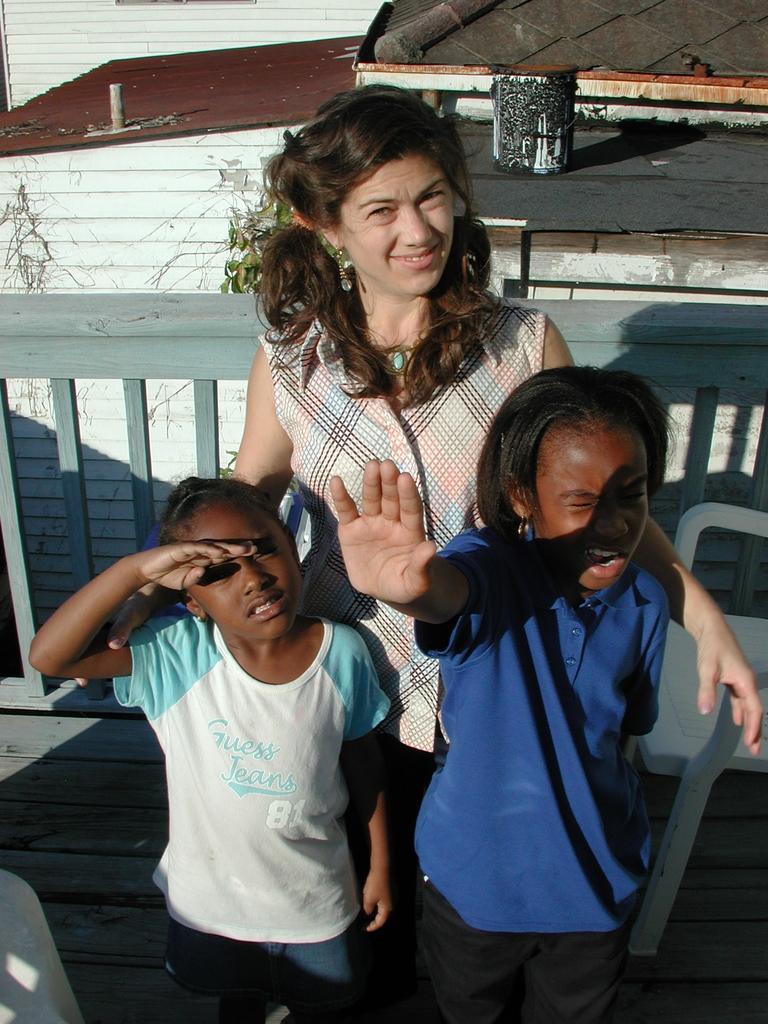Please provide a concise description of this image. In this image I can see few people are standing and wearing different color dress. I can see a chair, fencing and few objects at back. 